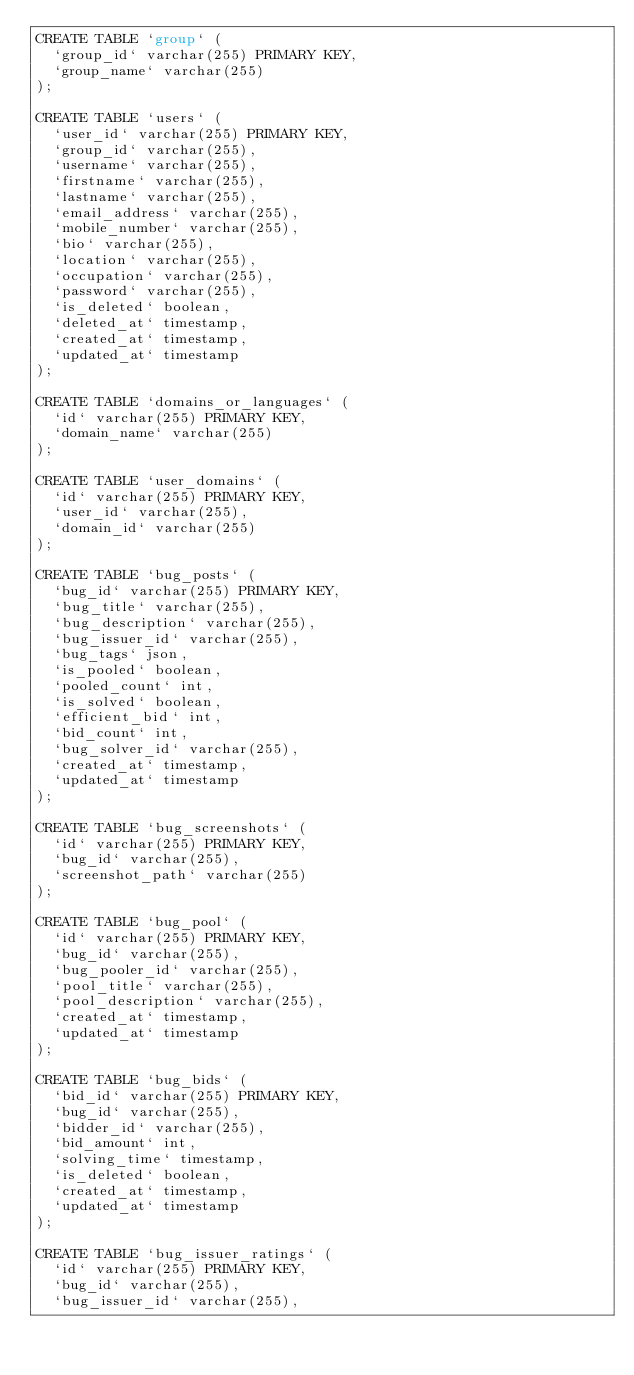<code> <loc_0><loc_0><loc_500><loc_500><_SQL_>CREATE TABLE `group` (
  `group_id` varchar(255) PRIMARY KEY,
  `group_name` varchar(255)
);

CREATE TABLE `users` (
  `user_id` varchar(255) PRIMARY KEY,
  `group_id` varchar(255),
  `username` varchar(255),
  `firstname` varchar(255),
  `lastname` varchar(255),
  `email_address` varchar(255),
  `mobile_number` varchar(255),
  `bio` varchar(255),
  `location` varchar(255),
  `occupation` varchar(255),
  `password` varchar(255),
  `is_deleted` boolean,
  `deleted_at` timestamp,
  `created_at` timestamp,
  `updated_at` timestamp
);

CREATE TABLE `domains_or_languages` (
  `id` varchar(255) PRIMARY KEY,
  `domain_name` varchar(255)
);

CREATE TABLE `user_domains` (
  `id` varchar(255) PRIMARY KEY,
  `user_id` varchar(255),
  `domain_id` varchar(255)
);

CREATE TABLE `bug_posts` (
  `bug_id` varchar(255) PRIMARY KEY,
  `bug_title` varchar(255),
  `bug_description` varchar(255),
  `bug_issuer_id` varchar(255),
  `bug_tags` json,
  `is_pooled` boolean,
  `pooled_count` int,
  `is_solved` boolean,
  `efficient_bid` int,
  `bid_count` int,
  `bug_solver_id` varchar(255),
  `created_at` timestamp,
  `updated_at` timestamp
);

CREATE TABLE `bug_screenshots` (
  `id` varchar(255) PRIMARY KEY,
  `bug_id` varchar(255),
  `screenshot_path` varchar(255)
);

CREATE TABLE `bug_pool` (
  `id` varchar(255) PRIMARY KEY,
  `bug_id` varchar(255),
  `bug_pooler_id` varchar(255),
  `pool_title` varchar(255),
  `pool_description` varchar(255),
  `created_at` timestamp,
  `updated_at` timestamp
);

CREATE TABLE `bug_bids` (
  `bid_id` varchar(255) PRIMARY KEY,
  `bug_id` varchar(255),
  `bidder_id` varchar(255),
  `bid_amount` int,
  `solving_time` timestamp,
  `is_deleted` boolean,
  `created_at` timestamp,
  `updated_at` timestamp
);

CREATE TABLE `bug_issuer_ratings` (
  `id` varchar(255) PRIMARY KEY,
  `bug_id` varchar(255),
  `bug_issuer_id` varchar(255),</code> 